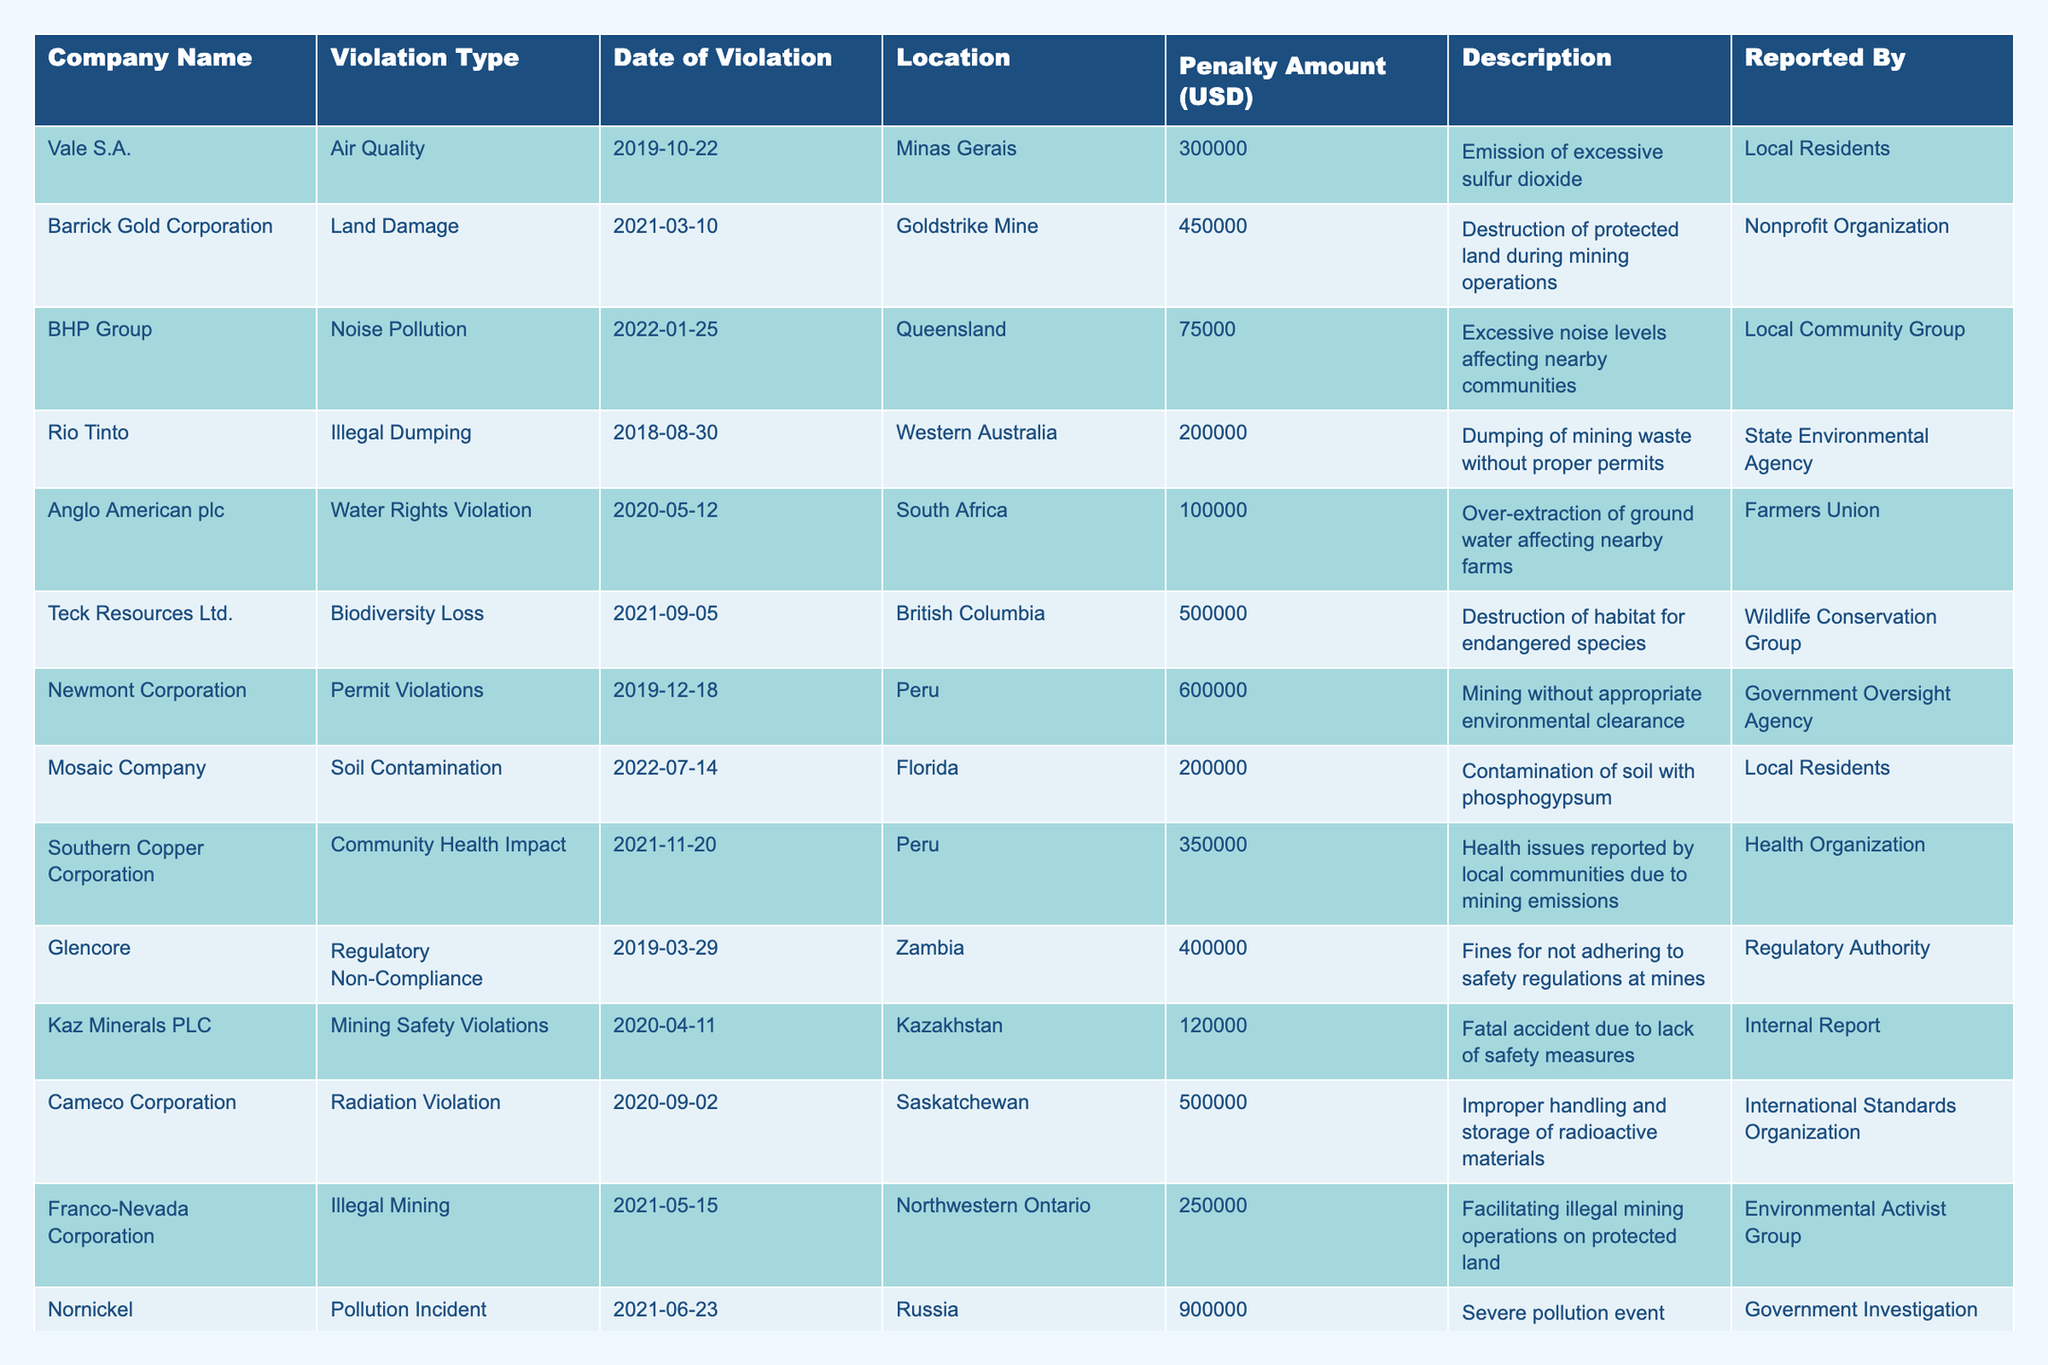What is the total penalty amount for all violations listed? To find the total penalty amount, we sum up all the penalty amounts listed for each company: 300000 + 450000 + 75000 + 200000 + 100000 + 500000 + 600000 + 200000 + 350000 + 400000 + 120000 + 500000 + 250000 + 900000 = 4,325,000
Answer: 4325000 Which company faced the highest penalty, and what was the amount? By reviewing the penalty amounts, we see that Nornickel faced the highest penalty at 900000.
Answer: Nornickel, 900000 Is there a company that has been penalized for illegal mining? Yes, Franco-Nevada Corporation has been penalized for illegal mining operations on protected land.
Answer: Yes How many companies faced penalties related to pollution? The companies involved in pollution violations include Vale S.A. (Air Quality), BHP Group (Noise Pollution), Rio Tinto (Illegal Dumping), Mosaic Company (Soil Contamination), Southern Copper Corporation (Community Health Impact), Nornickel (Pollution Incident), so there are 6 companies.
Answer: 6 What is the average penalty amount for all violations? The total penalties sum up to 4,325,000, and there are 14 violations, so the average penalty is 4,325,000 / 14 = 308,928.57, which rounds to 308928.57.
Answer: 308928.57 Did any company receive a penalty for biodiversity loss? Yes, Teck Resources Ltd. was penalized for biodiversity loss with a penalty amount of 500000.
Answer: Yes How many violations occurred in 2021? The years with violations in 2021 are Barrick Gold Corporation (March), Teck Resources Ltd. (September), Southern Copper Corporation (November), Franco-Nevada Corporation (May), and Nornickel (June), totaling 5 violations.
Answer: 5 Which violation type occurred most frequently among the listed companies? By reviewing the violation types, none are repeated, but pollution-related violations appear 4 times. However, since they are distinct types, they are the most common overall.
Answer: Pollution-related violations How many companies reported violations in Australia? The companies with violations in Australia are Rio Tinto (Illegal Dumping) and BHP Group (Noise Pollution), which accounts for 2 companies.
Answer: 2 What percentage of the total penalties does the highest penalty (Nornickel) represent? The highest penalty is 900000, and the total penalties are 4,325,000. To find the percentage, (900000 / 4325000) * 100 = 20.81%.
Answer: 20.81% 